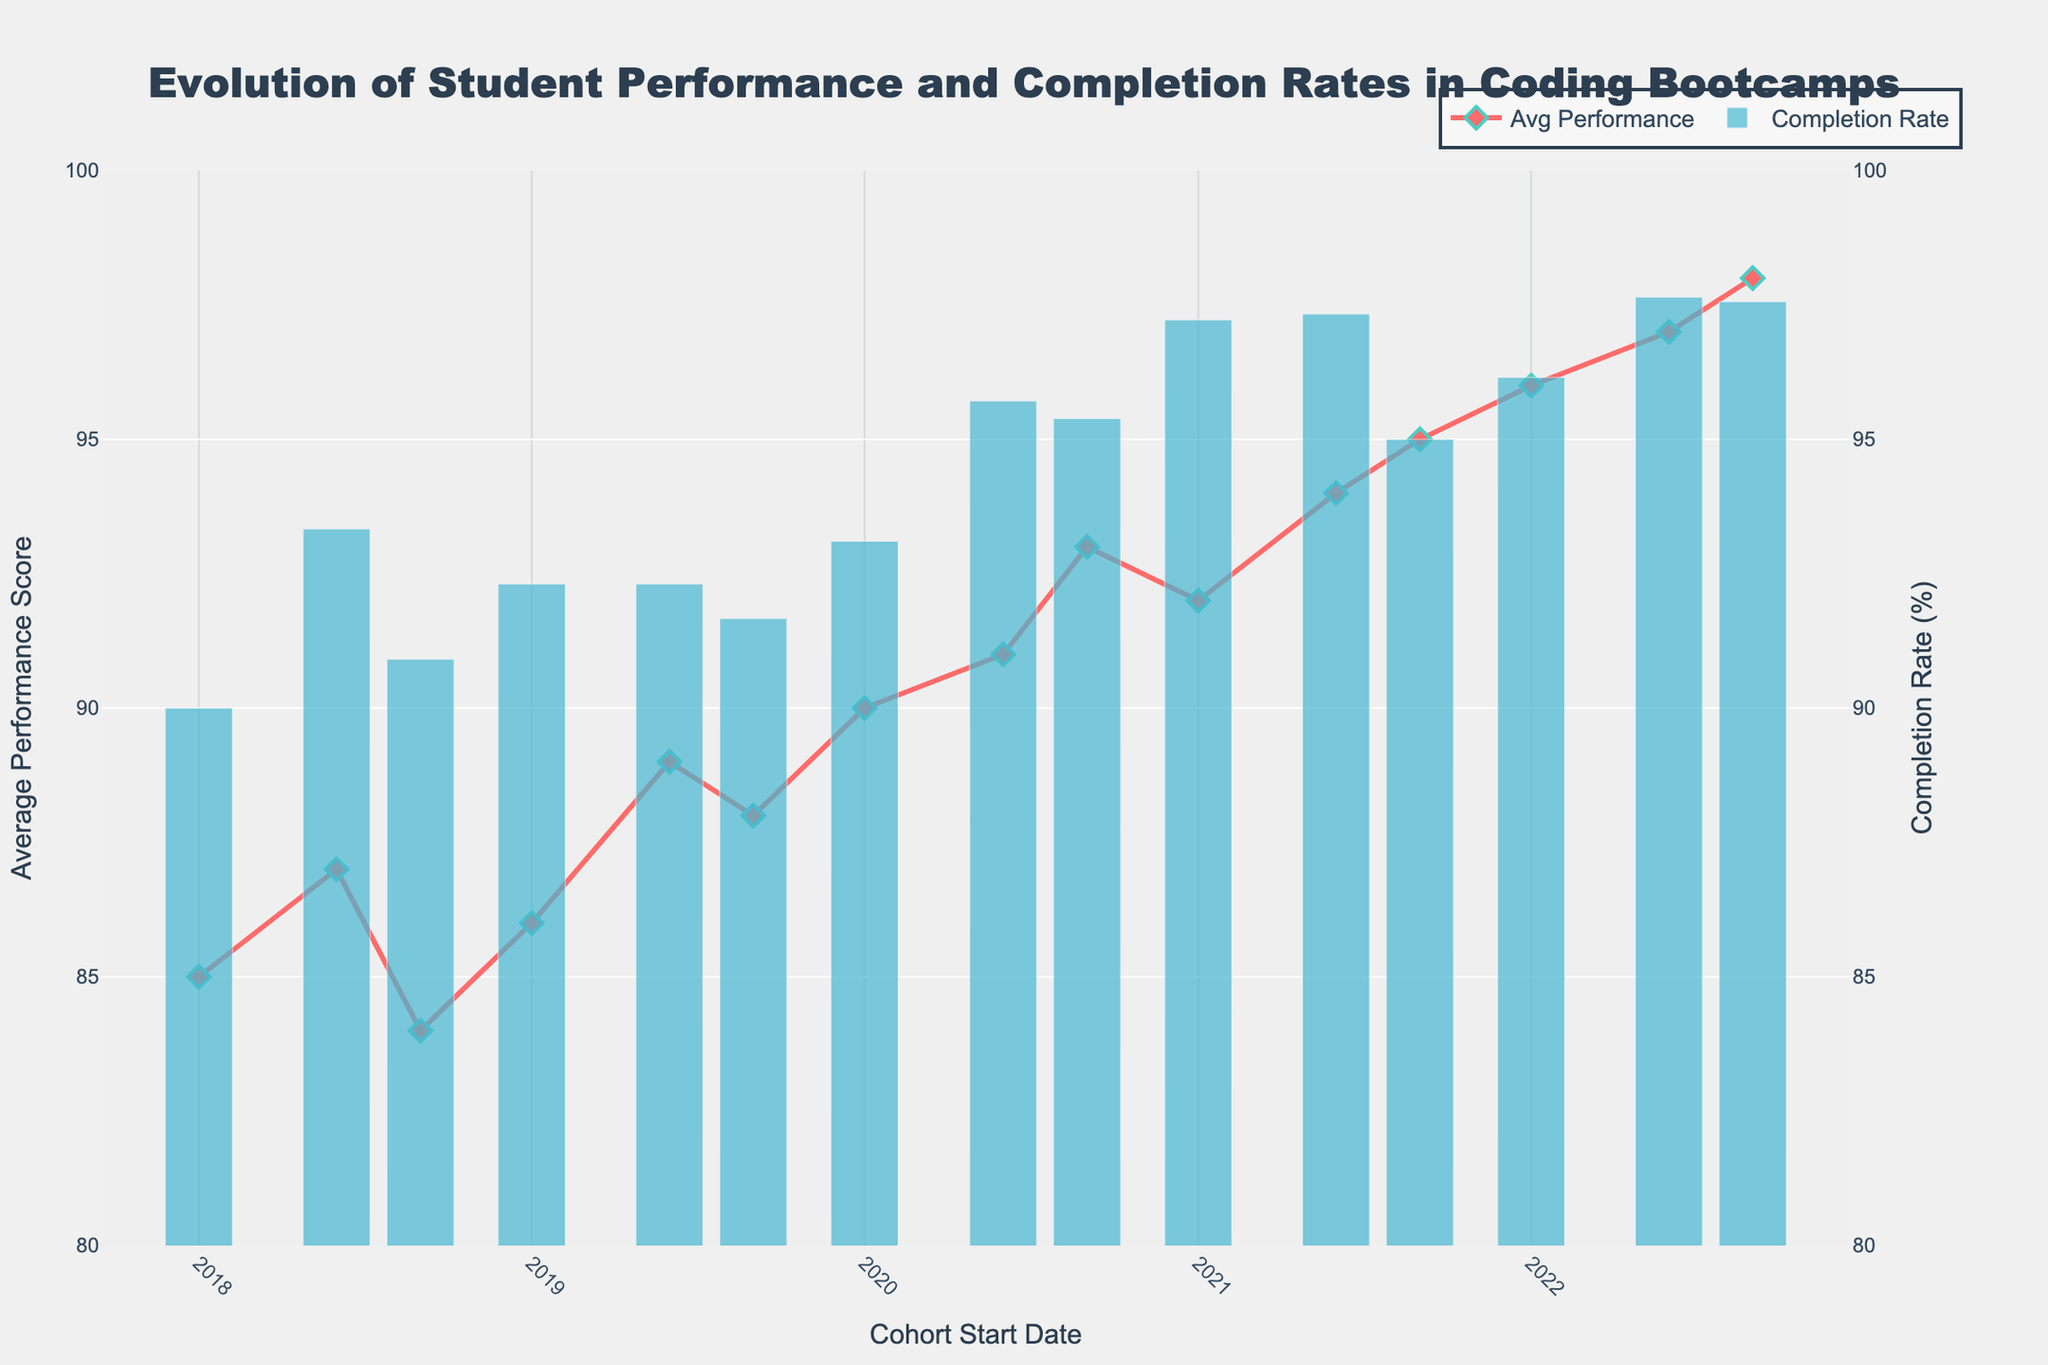What's the title of the figure? The title is located at the top of the figure. It reads, "Evolution of Student Performance and Completion Rates in Coding Bootcamps."
Answer: Evolution of Student Performance and Completion Rates in Coding Bootcamps What do the red diamonds represent in the figure? The red diamonds are used as markers for the "Average Performance Score" series. This is indicated in the legend by the line and marker combination colored in red.
Answer: Average Performance Score What metric on the left y-axis ranges between 80 and 100? By looking at the left y-axis, we can see that it is labeled "Average Performance Score" and ranges from 80 to 100.
Answer: Average Performance Score What's the highest average performance score recorded in the figure? The highest point on the "Average Performance Score" line is close to the 2022 Fall cohort, and it reaches a maximum of around 98.
Answer: 98 Which cohort has the lowest completion rate? By examining the blue bars representing completion rates, the lowest bar appears in the 2018 Winter cohort, where the completion rate is calculated as the lowest around 90%.
Answer: 90% in 2018 Winter How many total points are plotted on the "Average Performance Score" series? We have one point for each cohort. Counting all the cohorts from 2018 Winter to 2022 Fall, there are 14 points.
Answer: 14 What is the completion rate for the cohort starting in Summer 2021? The blue bar corresponding to the 2021 Summer cohort has a height close to 95%, which is the value for the completion rate.
Answer: 95% How did the average performance score change from Winter 2020 to Spring 2020? By observing the performance line from Winter 2020 to Summer 2020, the average performance score rises from 90 to 91.
Answer: Increased by 1 point Which cohort has the highest completion rate, and what is it? The highest bar is for the 2020 Summer cohort, with a completion rate of approximately 98%.
Answer: 98% for 2022 Fall What is the difference in average performance scores between the highest and lowest performing cohorts? The highest performing cohort has an average score of 98 (2022 Fall), and the lowest has an average score of 84 (2018 Fall). Subtracting these gives 98 - 84 = 14.
Answer: 14 